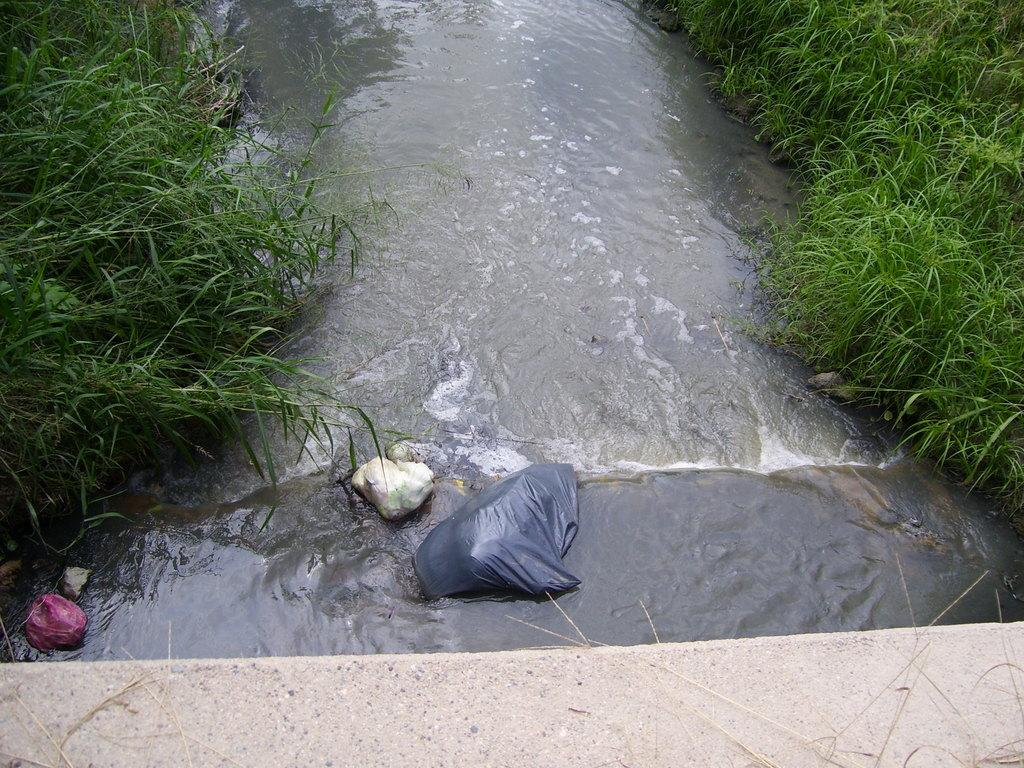What is covering the wall in the image? There is grass on the wall in the image. What can be seen floating in the water? There are colorful covers visible in the water. What type of vegetation is present on the right side of the image? There is green grass on the right side of the image. What type of vegetation is present on the left side of the image? There is green grass on the left side of the image. What type of fire can be seen burning in the image? There is no fire present in the image. What process is being carried out in the image? The image does not depict a specific process; it shows grass on a wall and colorful covers in water. 